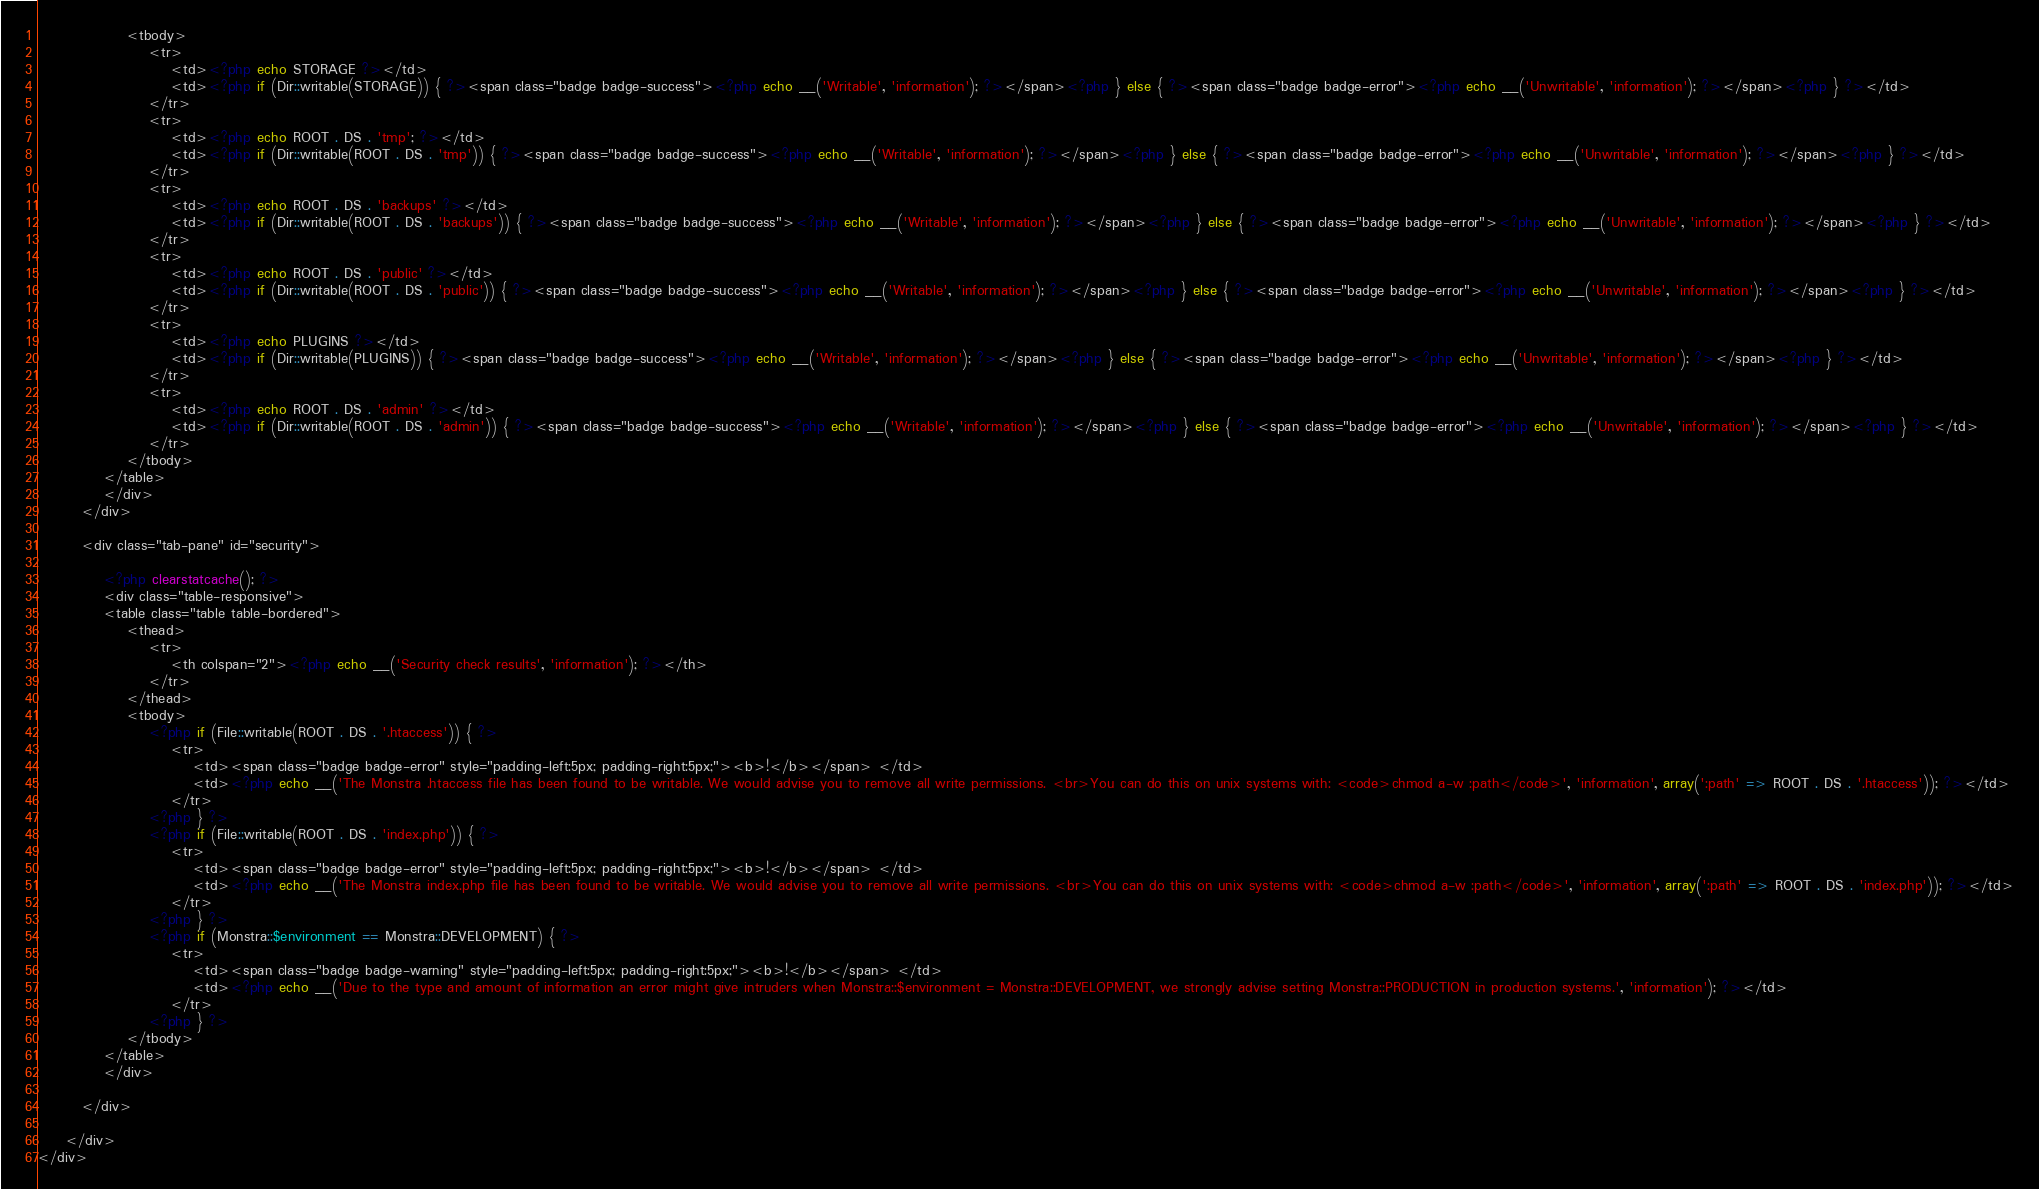Convert code to text. <code><loc_0><loc_0><loc_500><loc_500><_PHP_>                <tbody>
                    <tr>
                        <td><?php echo STORAGE ?></td>
                        <td><?php if (Dir::writable(STORAGE)) { ?><span class="badge badge-success"><?php echo __('Writable', 'information'); ?></span><?php } else { ?><span class="badge badge-error"><?php echo __('Unwritable', 'information'); ?></span><?php } ?></td>
                    </tr>
                    <tr>
                        <td><?php echo ROOT . DS . 'tmp'; ?></td>
                        <td><?php if (Dir::writable(ROOT . DS . 'tmp')) { ?><span class="badge badge-success"><?php echo __('Writable', 'information'); ?></span><?php } else { ?><span class="badge badge-error"><?php echo __('Unwritable', 'information'); ?></span><?php } ?></td>
                    </tr>
                    <tr>
                        <td><?php echo ROOT . DS . 'backups' ?></td>
                        <td><?php if (Dir::writable(ROOT . DS . 'backups')) { ?><span class="badge badge-success"><?php echo __('Writable', 'information'); ?></span><?php } else { ?><span class="badge badge-error"><?php echo __('Unwritable', 'information'); ?></span><?php } ?></td>
                    </tr>
                    <tr>
                        <td><?php echo ROOT . DS . 'public' ?></td>
                        <td><?php if (Dir::writable(ROOT . DS . 'public')) { ?><span class="badge badge-success"><?php echo __('Writable', 'information'); ?></span><?php } else { ?><span class="badge badge-error"><?php echo __('Unwritable', 'information'); ?></span><?php } ?></td>
                    </tr>
                    <tr>
                        <td><?php echo PLUGINS ?></td>
                        <td><?php if (Dir::writable(PLUGINS)) { ?><span class="badge badge-success"><?php echo __('Writable', 'information'); ?></span><?php } else { ?><span class="badge badge-error"><?php echo __('Unwritable', 'information'); ?></span><?php } ?></td>
                    </tr>
                    <tr>
                        <td><?php echo ROOT . DS . 'admin' ?></td>
                        <td><?php if (Dir::writable(ROOT . DS . 'admin')) { ?><span class="badge badge-success"><?php echo __('Writable', 'information'); ?></span><?php } else { ?><span class="badge badge-error"><?php echo __('Unwritable', 'information'); ?></span><?php } ?></td>
                    </tr>
                </tbody>
            </table>
            </div>
        </div>

        <div class="tab-pane" id="security">

            <?php clearstatcache(); ?>
            <div class="table-responsive">
            <table class="table table-bordered">
                <thead>
                    <tr>
                        <th colspan="2"><?php echo __('Security check results', 'information'); ?></th>
                    </tr>
                </thead>
                <tbody>
                    <?php if (File::writable(ROOT . DS . '.htaccess')) { ?>
                        <tr>
                            <td><span class="badge badge-error" style="padding-left:5px; padding-right:5px;"><b>!</b></span> </td>
                            <td><?php echo __('The Monstra .htaccess file has been found to be writable. We would advise you to remove all write permissions. <br>You can do this on unix systems with: <code>chmod a-w :path</code>', 'information', array(':path' => ROOT . DS . '.htaccess')); ?></td>
                        </tr>
                    <?php } ?>
                    <?php if (File::writable(ROOT . DS . 'index.php')) { ?>
                        <tr>
                            <td><span class="badge badge-error" style="padding-left:5px; padding-right:5px;"><b>!</b></span> </td>
                            <td><?php echo __('The Monstra index.php file has been found to be writable. We would advise you to remove all write permissions. <br>You can do this on unix systems with: <code>chmod a-w :path</code>', 'information', array(':path' => ROOT . DS . 'index.php')); ?></td>
                        </tr>
                    <?php } ?>
                    <?php if (Monstra::$environment == Monstra::DEVELOPMENT) { ?>
                        <tr>
                            <td><span class="badge badge-warning" style="padding-left:5px; padding-right:5px;"><b>!</b></span> </td>
                            <td><?php echo __('Due to the type and amount of information an error might give intruders when Monstra::$environment = Monstra::DEVELOPMENT, we strongly advise setting Monstra::PRODUCTION in production systems.', 'information'); ?></td>
                        </tr>
                    <?php } ?>
                </tbody>
            </table>
            </div>

        </div>

     </div>
</div>
</code> 